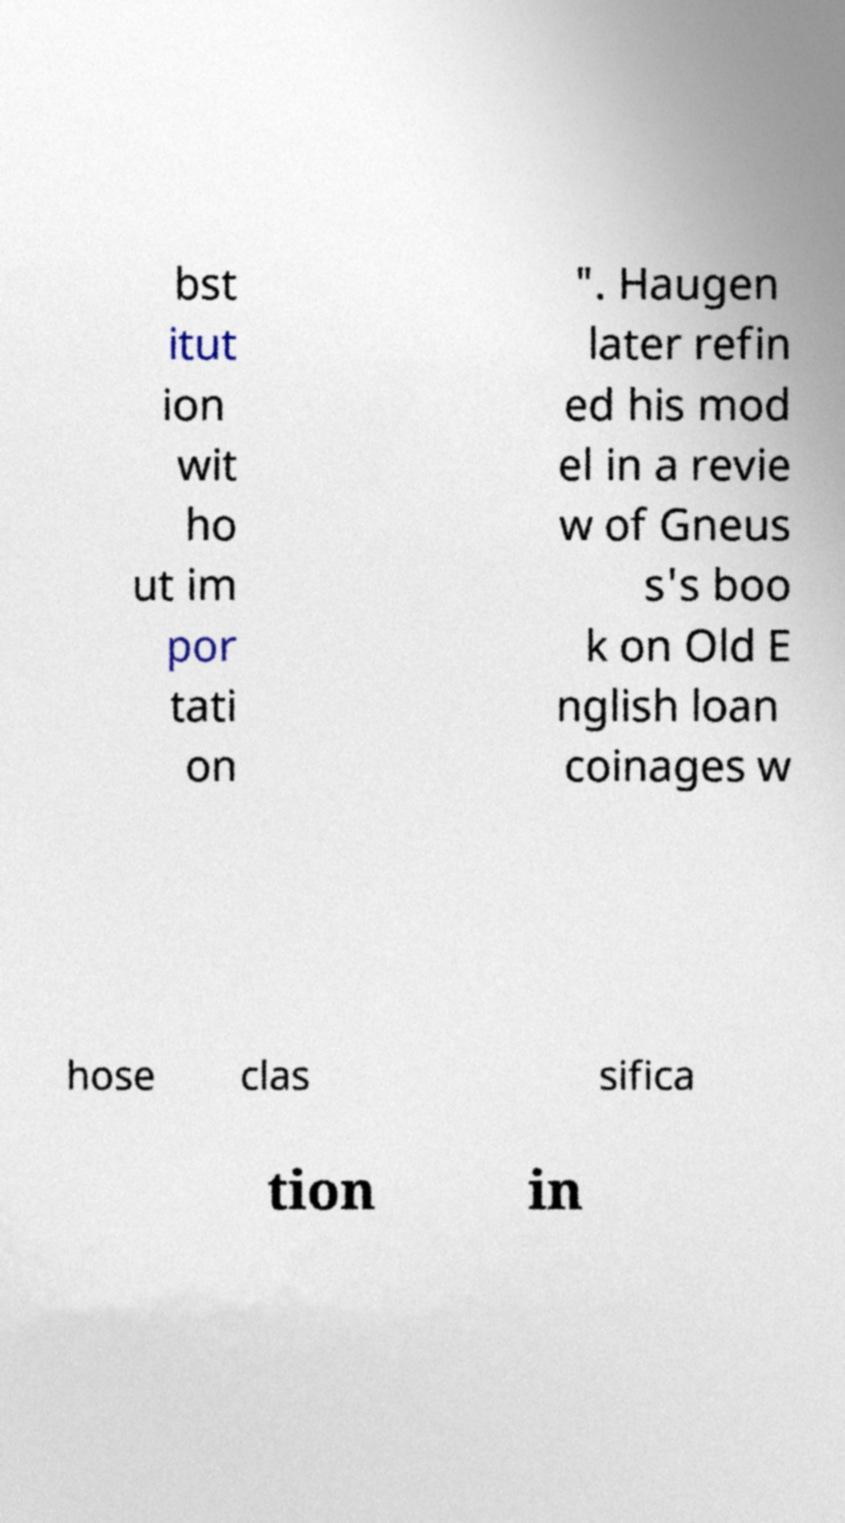I need the written content from this picture converted into text. Can you do that? bst itut ion wit ho ut im por tati on ". Haugen later refin ed his mod el in a revie w of Gneus s's boo k on Old E nglish loan coinages w hose clas sifica tion in 